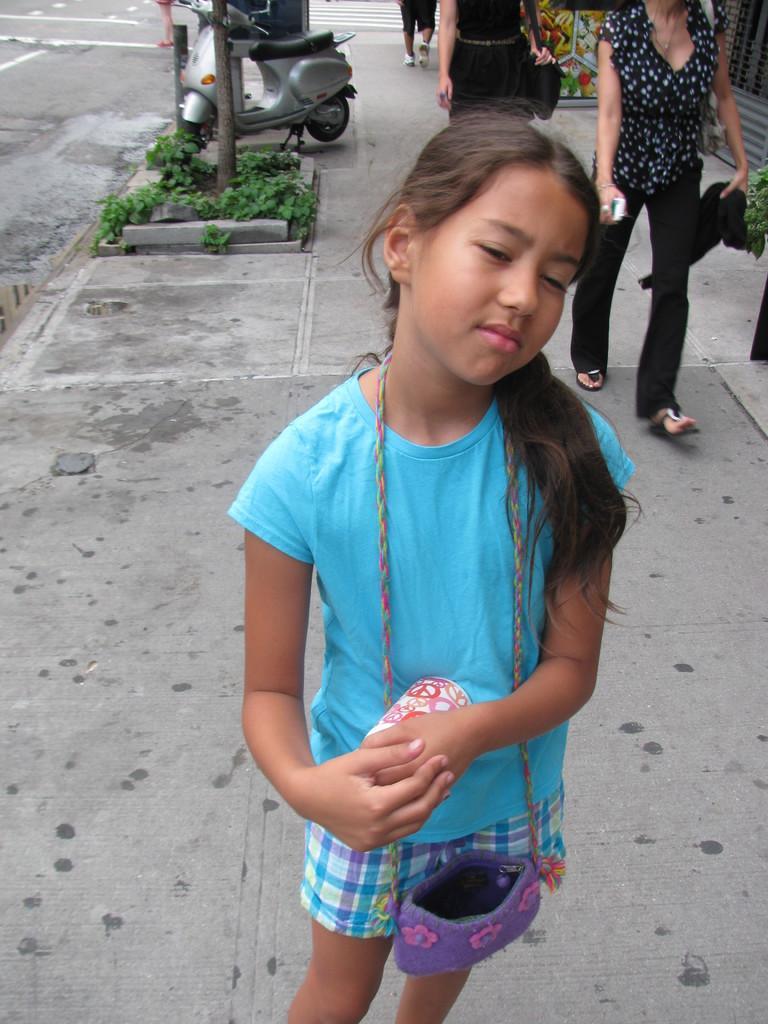In one or two sentences, can you explain what this image depicts? In this image, I see a girl who is wearing a bag and is on the path. In the background I see few plants, a vehicle and 3 person and road on the left. 